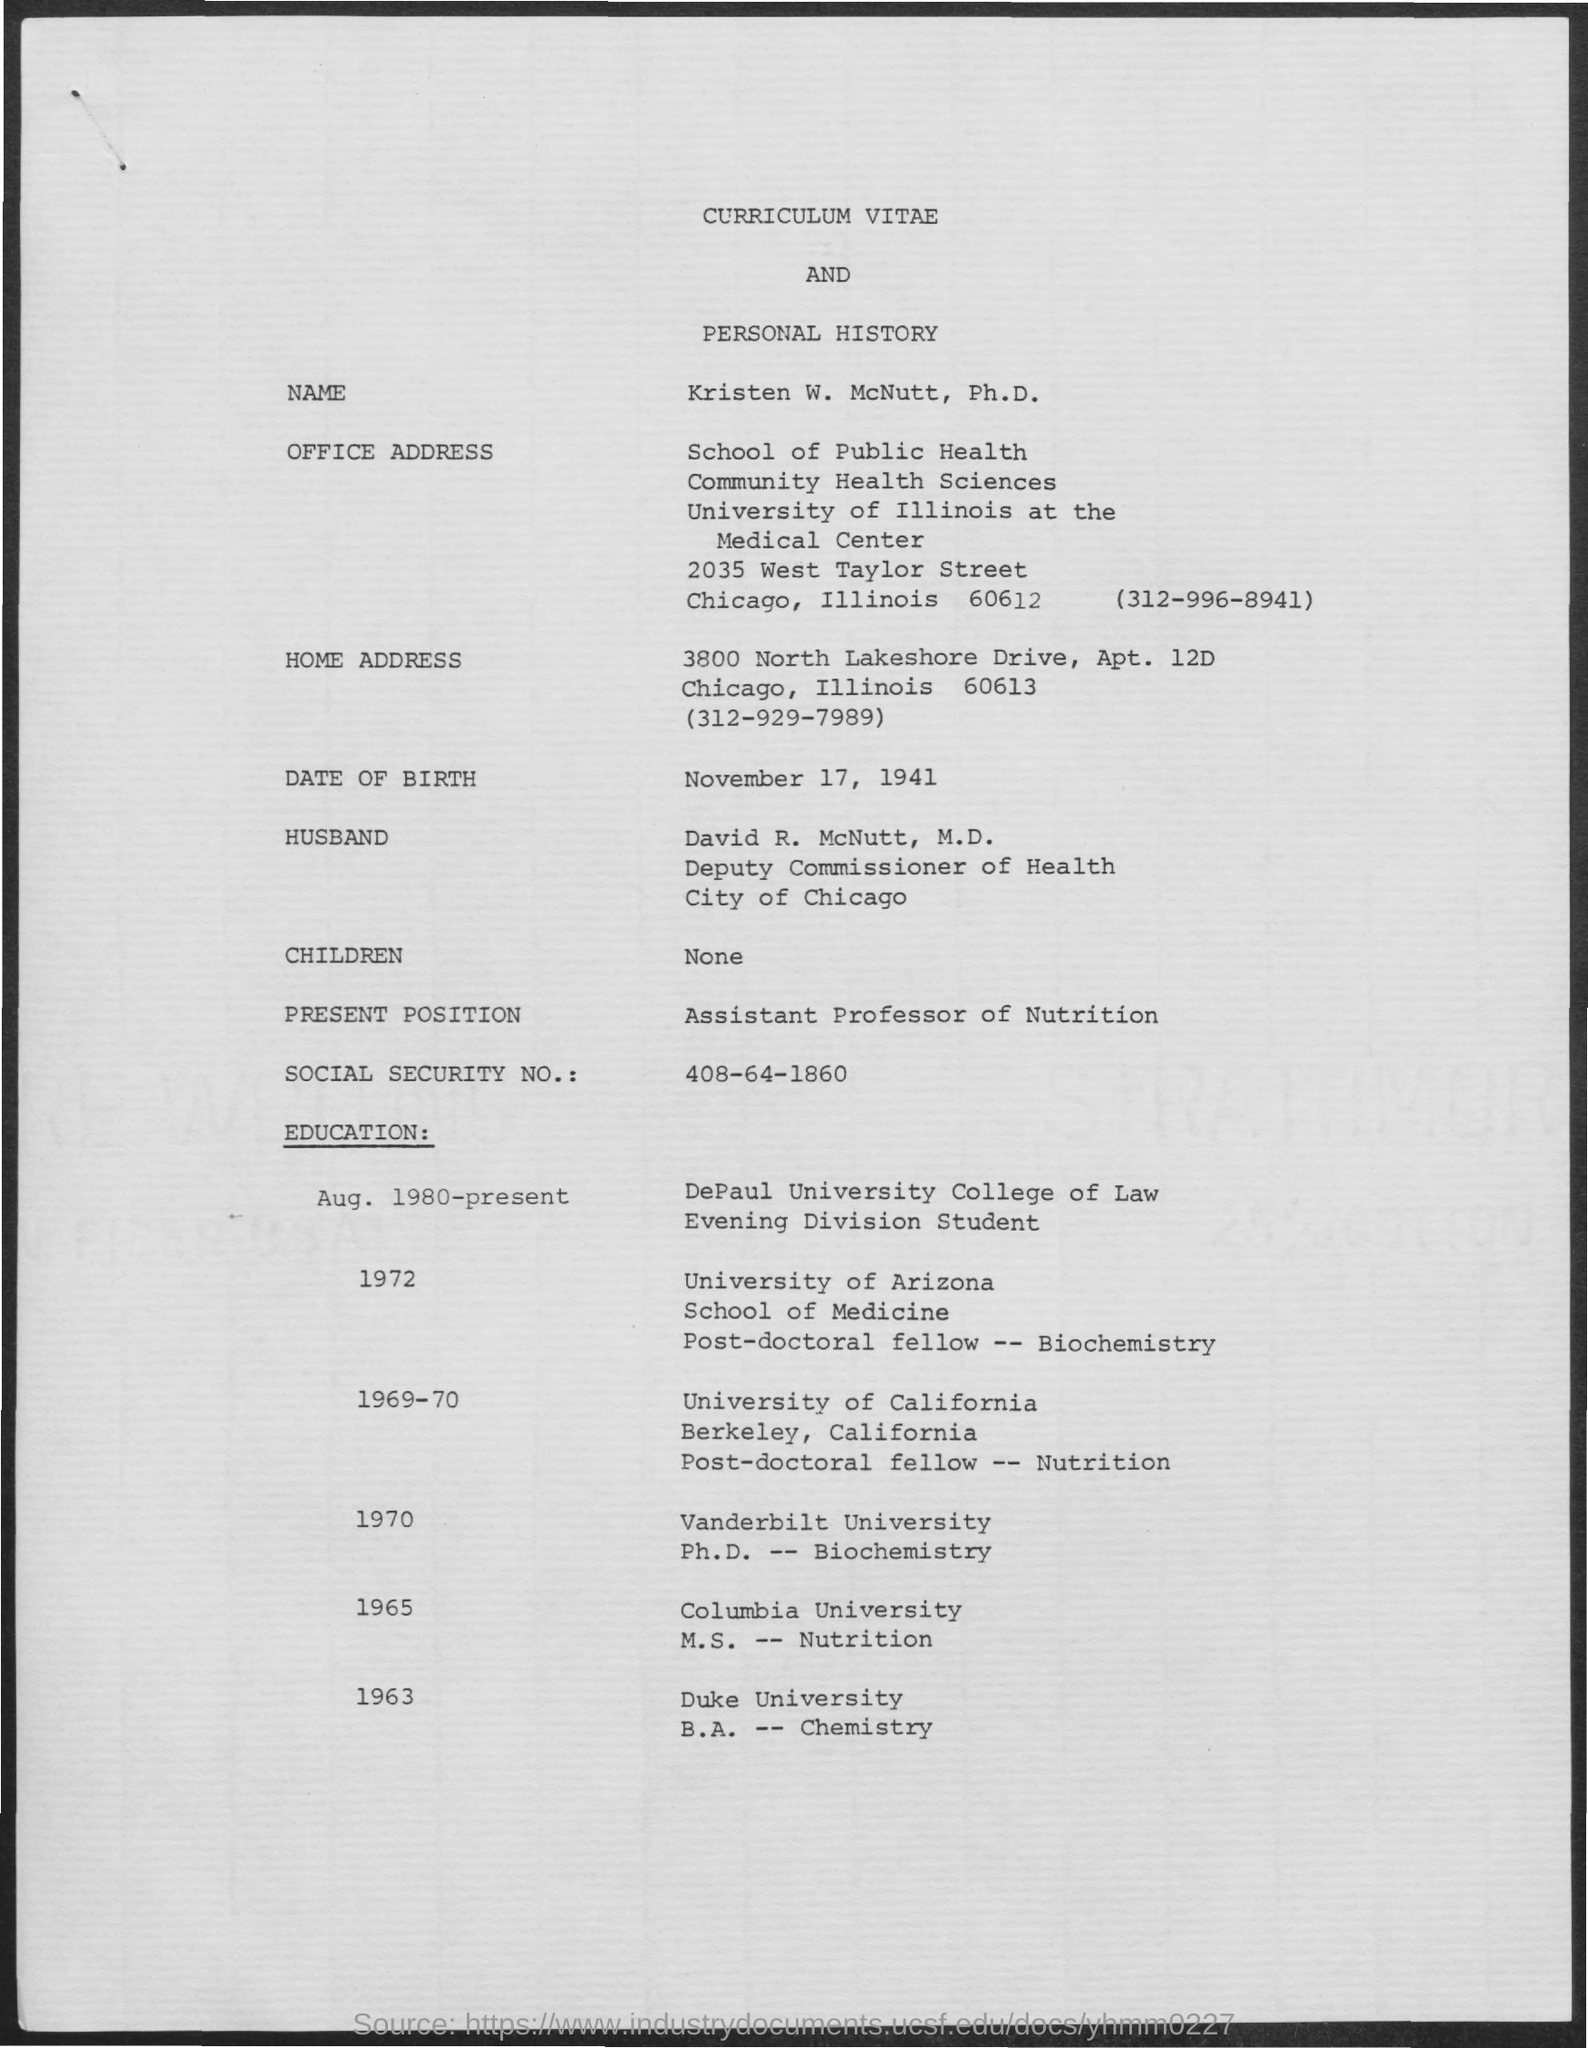What is the Date of Birth?
Provide a short and direct response. November 17, 1941. What is the social security No.?
Ensure brevity in your answer.  408-64-1860. What is the present position?
Keep it short and to the point. Assistant Professor of Nutrition. 